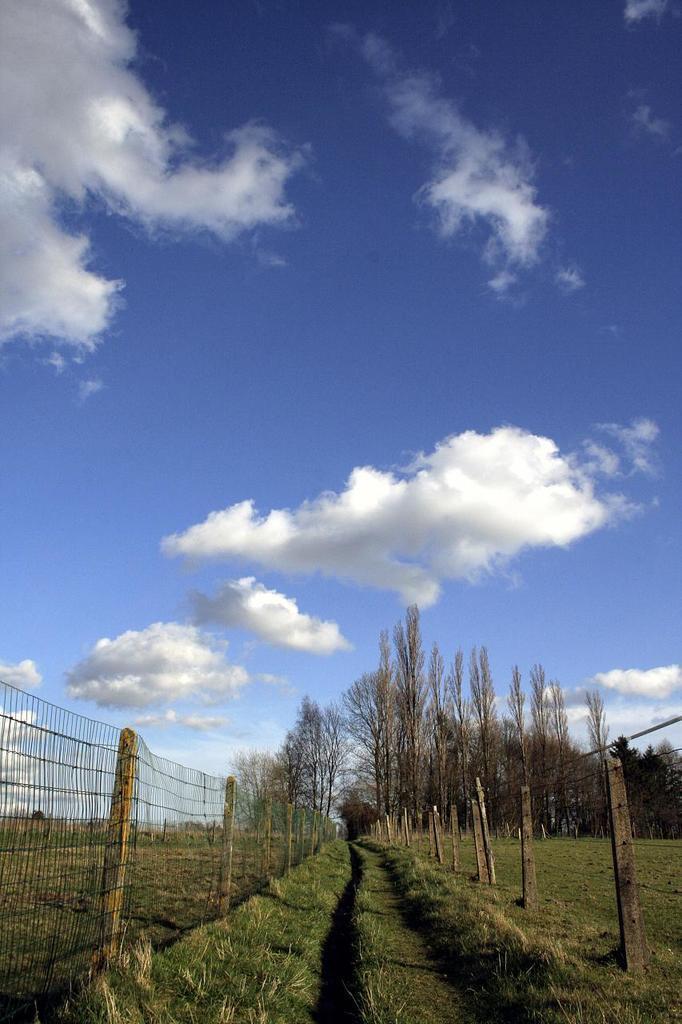Can you describe this image briefly? In this image I can see few dry trees, grass and the fencing. The sky is in blue and white color. 